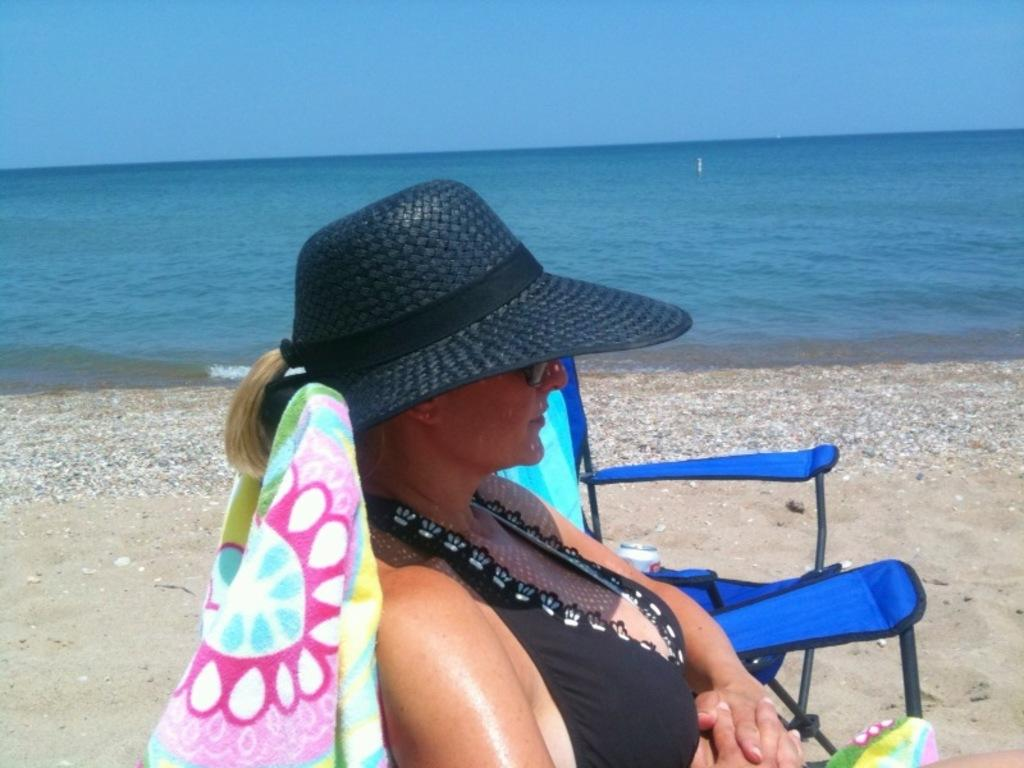What is the woman in the image doing? The woman is sitting on a chair in the image. Can you describe the woman's attire? The woman is wearing a cap. How many chairs are visible in the image? There are two chairs visible in the image. What is on the second chair? There is a cloth on the second chair. What can be seen in the background of the image? Water is visible in the image, and the sky is blue. What type of zebra can be seen playing chess with the woman in the image? There is no zebra or chessboard present in the image. Is the woman in the image part of an army? There is no indication in the image that the woman is part of an army. 